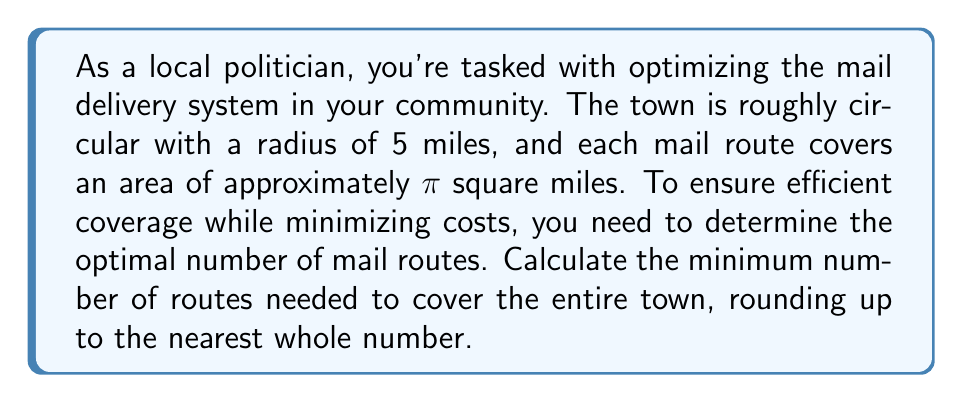Teach me how to tackle this problem. To solve this problem, we need to follow these steps:

1. Calculate the total area of the town:
   The town is circular with a radius of 5 miles.
   Area of a circle is given by the formula: $A = \pi r^2$
   $$A = \pi \cdot 5^2 = 25\pi \text{ square miles}$$

2. Determine the area covered by each route:
   Each route covers approximately $\pi$ square miles.

3. Calculate the number of routes needed:
   Number of routes = Total area / Area per route
   $$\text{Number of routes} = \frac{25\pi}{\pi} = 25$$

4. Round up to the nearest whole number:
   Since we can't have a fractional number of routes, and we need to ensure complete coverage, we round up to the nearest whole number.

   In this case, 25 is already a whole number, so no rounding is necessary.

This solution ensures that the entire town is covered efficiently while using the minimum number of routes possible.
Answer: The optimal number of mail routes needed to efficiently cover the town is 25. 